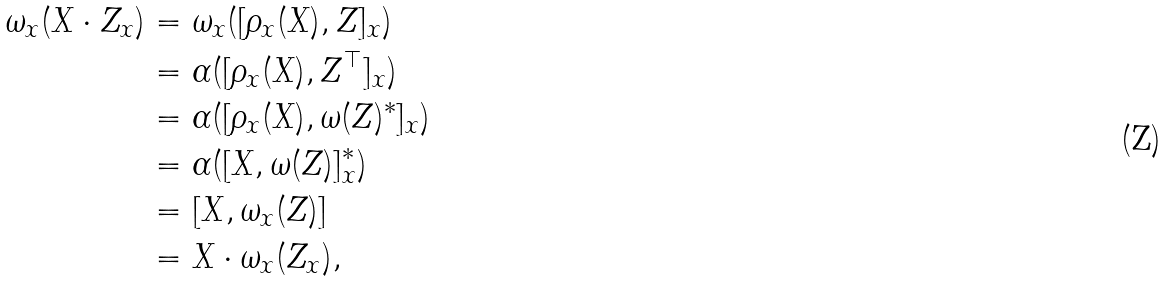Convert formula to latex. <formula><loc_0><loc_0><loc_500><loc_500>\omega _ { x } ( X \cdot Z _ { x } ) & = \omega _ { x } ( [ \rho _ { x } ( X ) , Z ] _ { x } ) \\ & = \alpha ( [ \rho _ { x } ( X ) , Z ^ { \top } ] _ { x } ) \\ & = \alpha ( [ \rho _ { x } ( X ) , \omega ( Z ) ^ { * } ] _ { x } ) \\ & = \alpha ( [ X , \omega ( Z ) ] ^ { * } _ { x } ) \\ & = [ X , \omega _ { x } ( Z ) ] \\ & = X \cdot \omega _ { x } ( Z _ { x } ) ,</formula> 